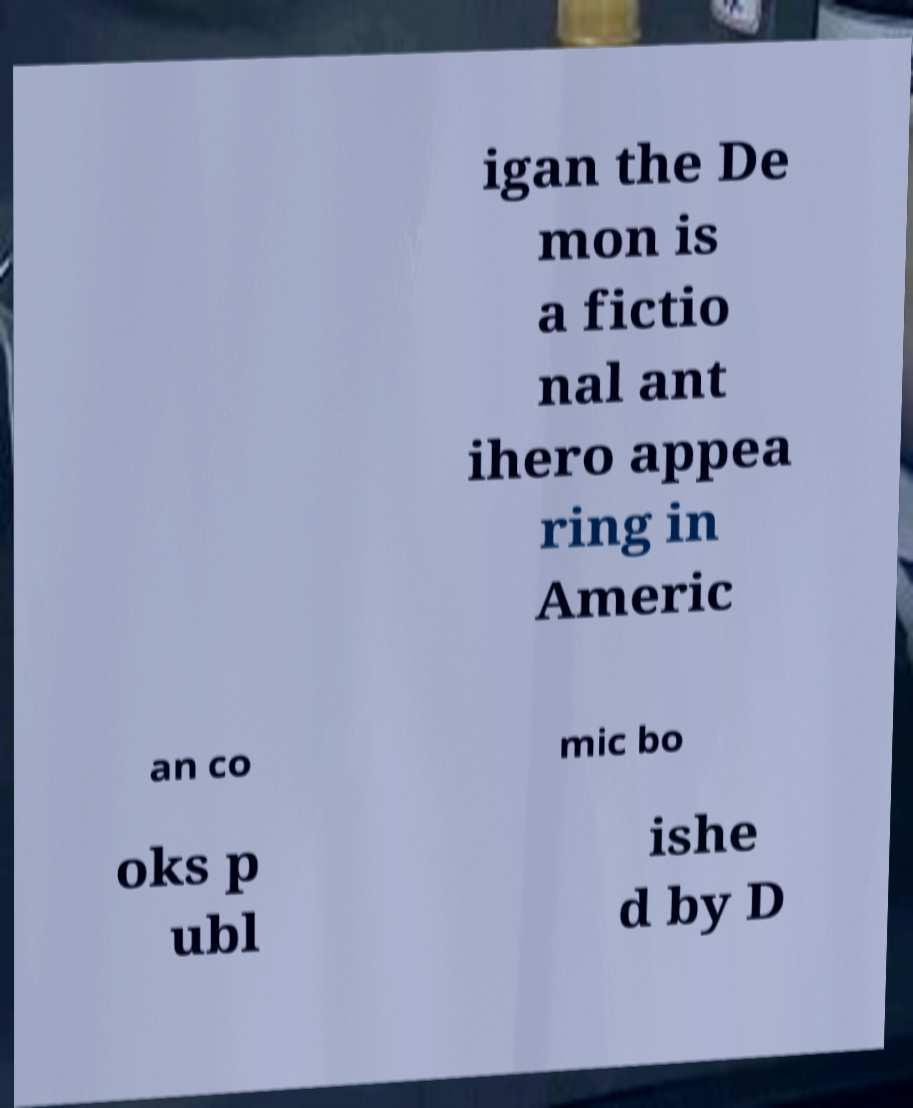Please read and relay the text visible in this image. What does it say? igan the De mon is a fictio nal ant ihero appea ring in Americ an co mic bo oks p ubl ishe d by D 